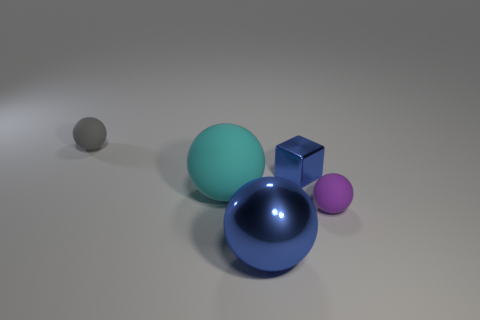How many small objects are made of the same material as the small blue block?
Make the answer very short. 0. How many things are either tiny purple metallic things or spheres on the right side of the blue shiny cube?
Offer a terse response. 1. Is the big ball behind the purple object made of the same material as the small gray ball?
Ensure brevity in your answer.  Yes. The other object that is the same size as the cyan rubber thing is what color?
Your response must be concise. Blue. Is there another metallic thing that has the same shape as the large cyan object?
Offer a terse response. Yes. There is a tiny sphere to the left of the tiny rubber ball to the right of the tiny rubber thing that is to the left of the big blue object; what color is it?
Provide a short and direct response. Gray. What number of shiny objects are blue blocks or large gray cubes?
Give a very brief answer. 1. Is the number of matte objects behind the large cyan matte ball greater than the number of matte spheres behind the tiny purple rubber thing?
Provide a short and direct response. No. What number of other objects are there of the same size as the metallic block?
Your answer should be very brief. 2. What is the size of the cube that is in front of the tiny thing that is left of the cyan ball?
Give a very brief answer. Small. 